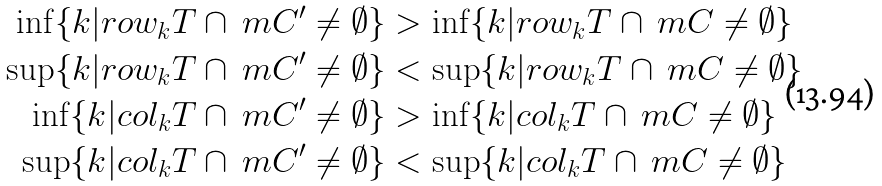<formula> <loc_0><loc_0><loc_500><loc_500>\inf \{ k | r o w _ { k } T \cap \ m C ^ { \prime } \neq \emptyset \} & > \inf \{ k | r o w _ { k } T \cap \ m C \neq \emptyset \} \\ \sup \{ k | r o w _ { k } T \cap \ m C ^ { \prime } \neq \emptyset \} & < \sup \{ k | r o w _ { k } T \cap \ m C \neq \emptyset \} \\ \inf \{ k | c o l _ { k } T \cap \ m C ^ { \prime } \neq \emptyset \} & > \inf \{ k | c o l _ { k } T \cap \ m C \neq \emptyset \} \\ \sup \{ k | c o l _ { k } T \cap \ m C ^ { \prime } \neq \emptyset \} & < \sup \{ k | c o l _ { k } T \cap \ m C \neq \emptyset \} \\</formula> 